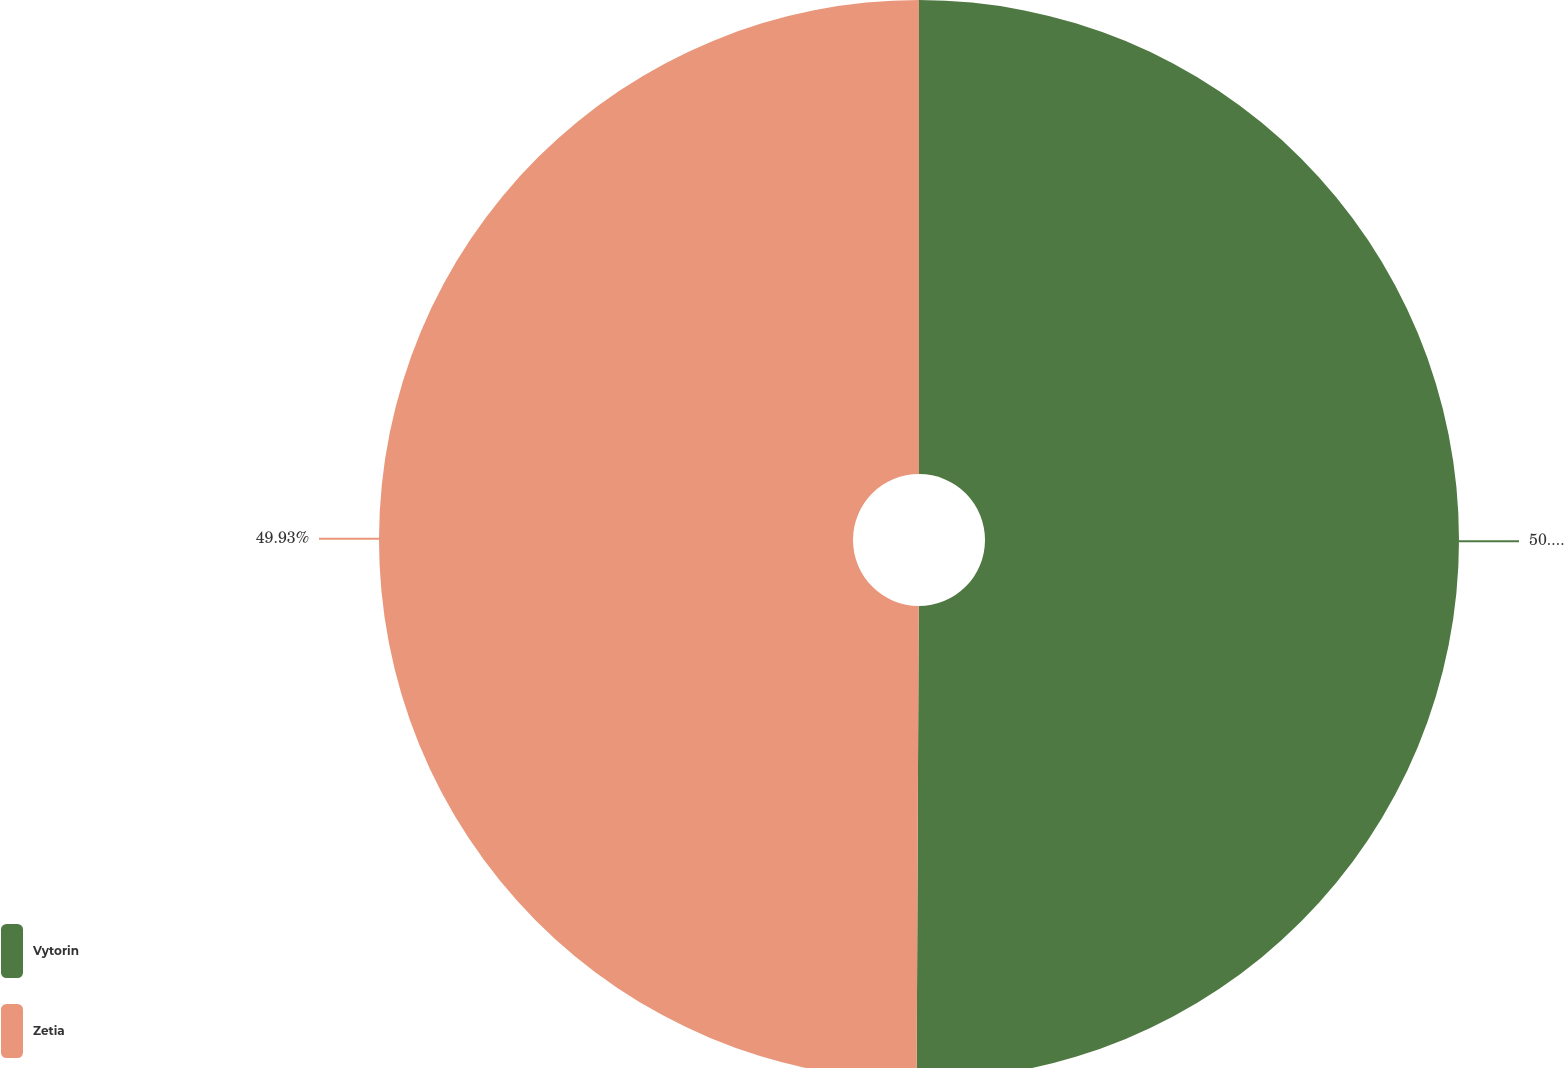<chart> <loc_0><loc_0><loc_500><loc_500><pie_chart><fcel>Vytorin<fcel>Zetia<nl><fcel>50.07%<fcel>49.93%<nl></chart> 